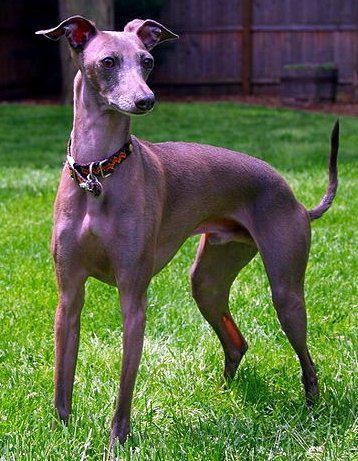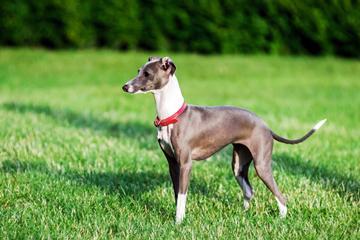The first image is the image on the left, the second image is the image on the right. Analyze the images presented: Is the assertion "In all photos, all four legs are visible." valid? Answer yes or no. Yes. 